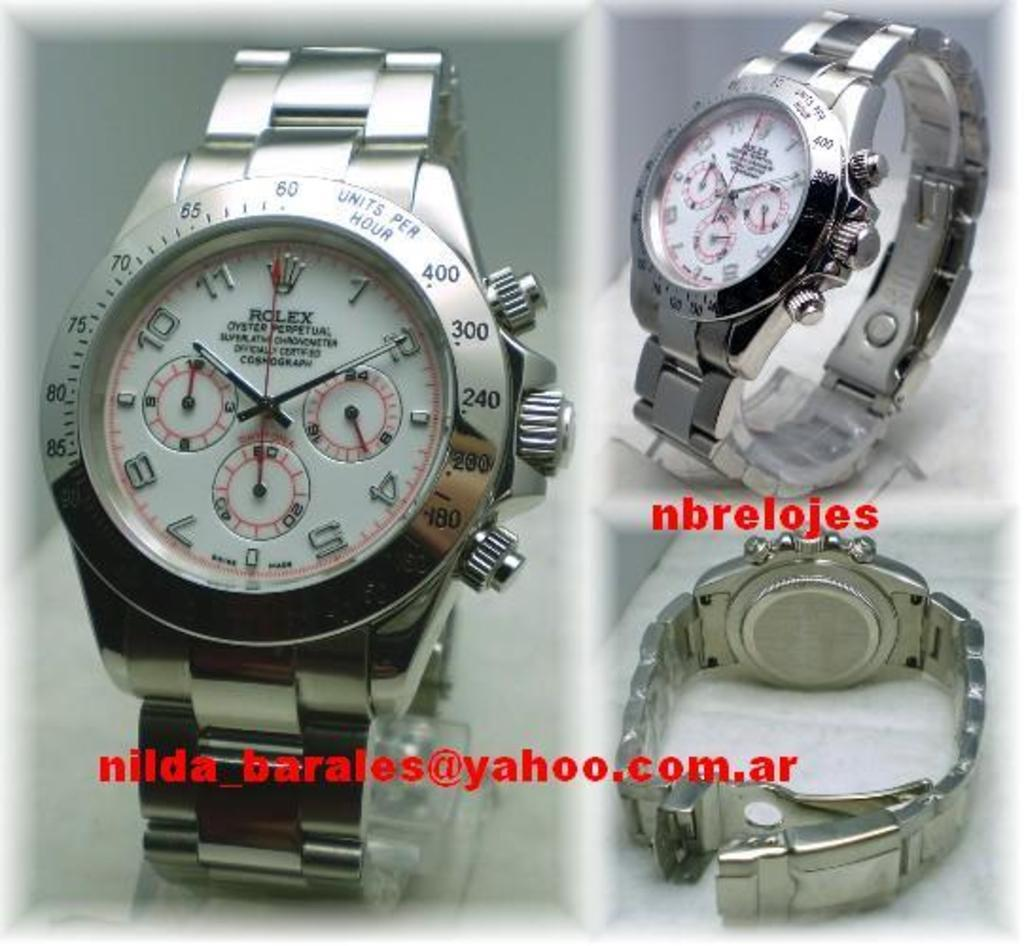<image>
Write a terse but informative summary of the picture. a rolex watch is shown from three angles 